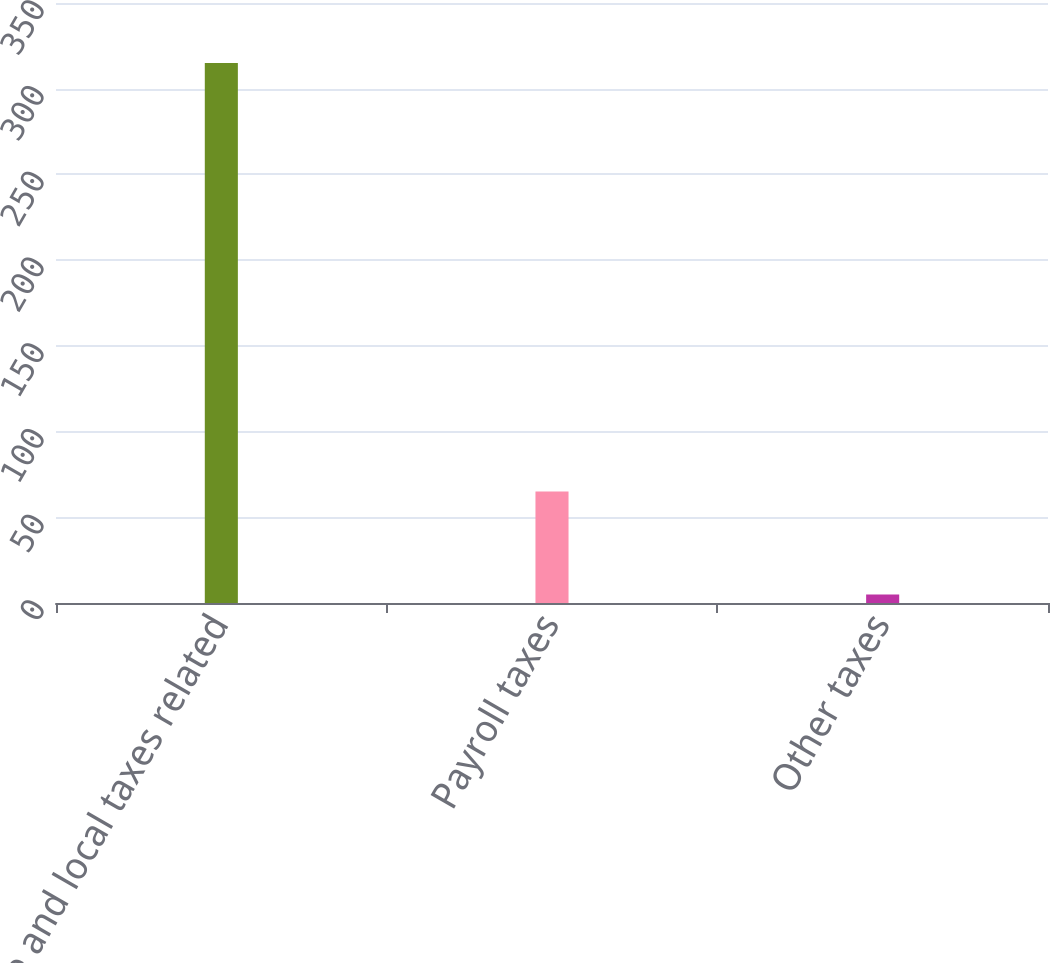Convert chart. <chart><loc_0><loc_0><loc_500><loc_500><bar_chart><fcel>State and local taxes related<fcel>Payroll taxes<fcel>Other taxes<nl><fcel>315<fcel>65<fcel>5<nl></chart> 